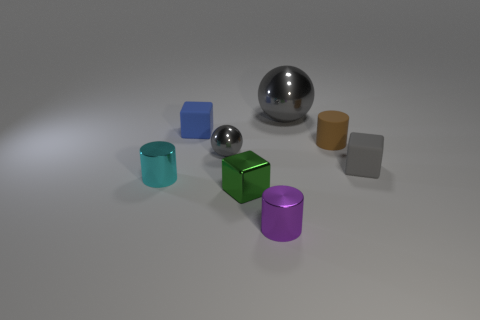What size is the metallic object that is the same shape as the blue matte object?
Offer a very short reply. Small. Is there any other thing that has the same size as the matte cylinder?
Your answer should be very brief. Yes. The cylinder in front of the tiny cyan metallic cylinder is what color?
Your answer should be compact. Purple. There is a tiny cylinder in front of the metal cylinder that is behind the small purple cylinder that is in front of the blue block; what is its material?
Provide a short and direct response. Metal. There is a gray metallic ball behind the rubber object left of the green cube; what size is it?
Your answer should be compact. Large. What color is the other rubber object that is the same shape as the purple object?
Give a very brief answer. Brown. How many other shiny balls are the same color as the large sphere?
Make the answer very short. 1. Do the blue cube and the purple metal cylinder have the same size?
Your answer should be very brief. Yes. What material is the tiny green thing?
Ensure brevity in your answer.  Metal. There is a block that is the same material as the cyan cylinder; what is its color?
Your answer should be very brief. Green. 